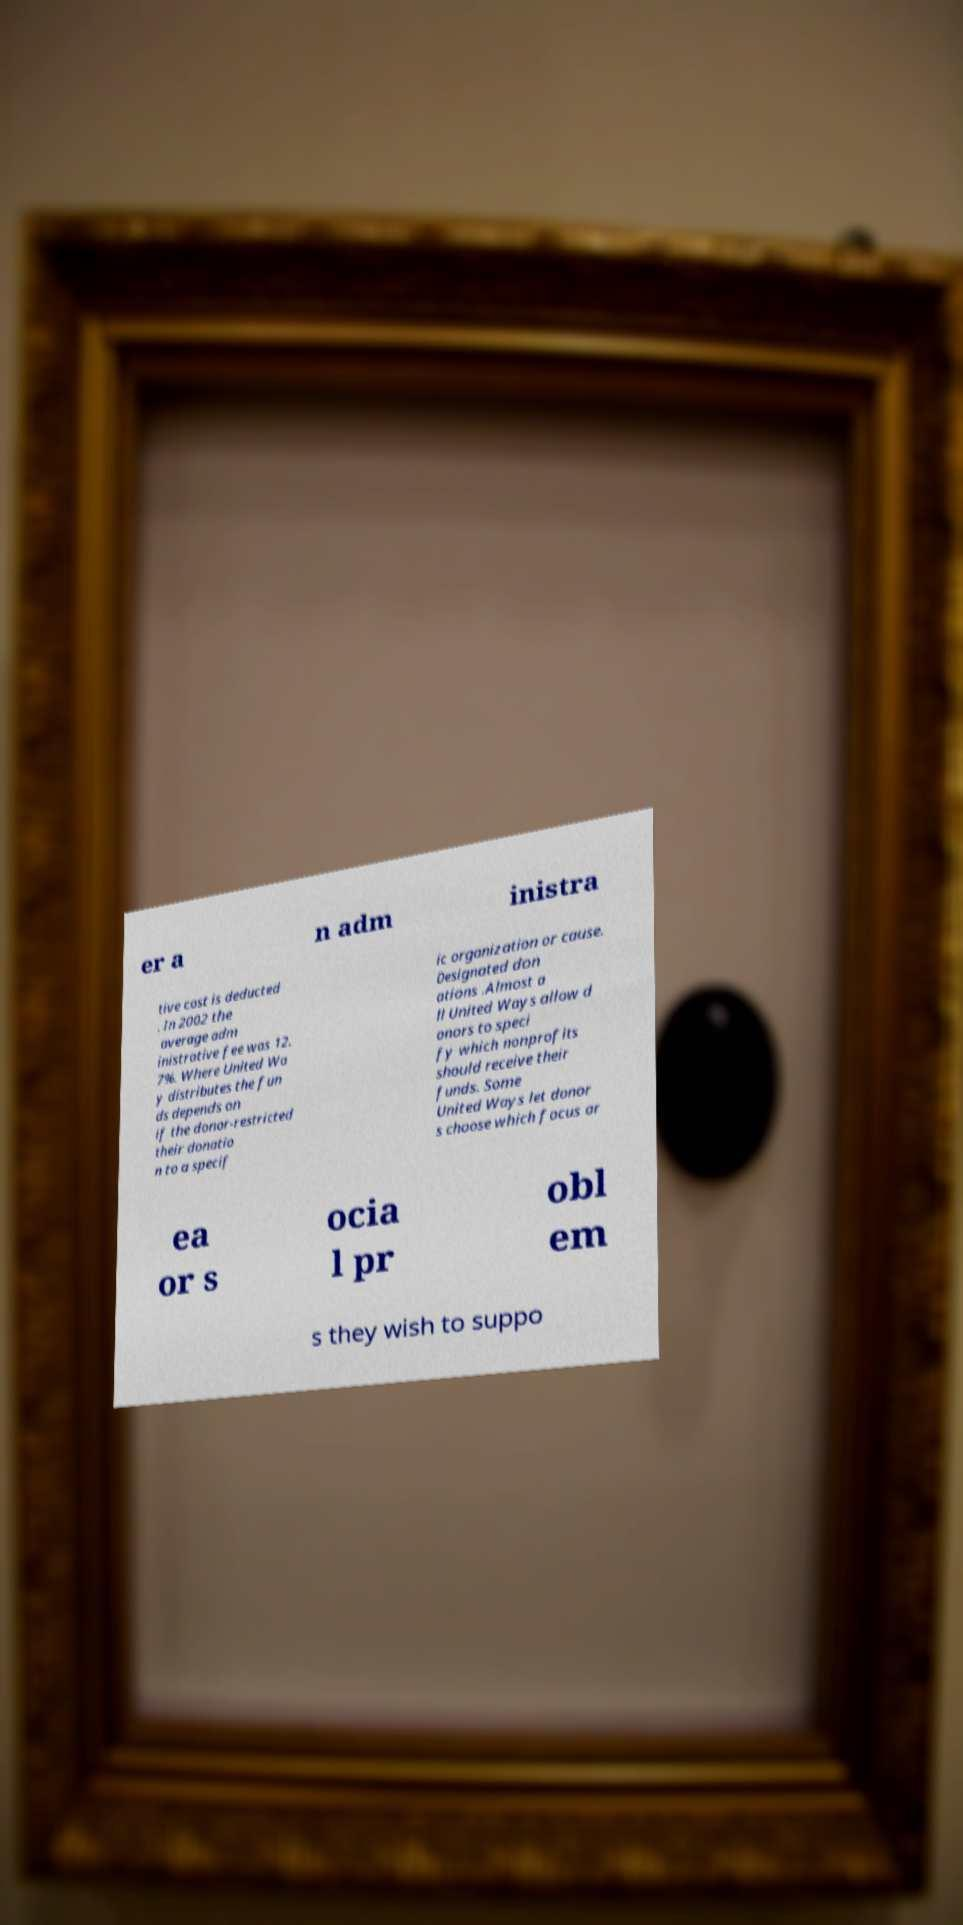What messages or text are displayed in this image? I need them in a readable, typed format. er a n adm inistra tive cost is deducted . In 2002 the average adm inistrative fee was 12. 7%. Where United Wa y distributes the fun ds depends on if the donor-restricted their donatio n to a specif ic organization or cause. Designated don ations .Almost a ll United Ways allow d onors to speci fy which nonprofits should receive their funds. Some United Ways let donor s choose which focus ar ea or s ocia l pr obl em s they wish to suppo 